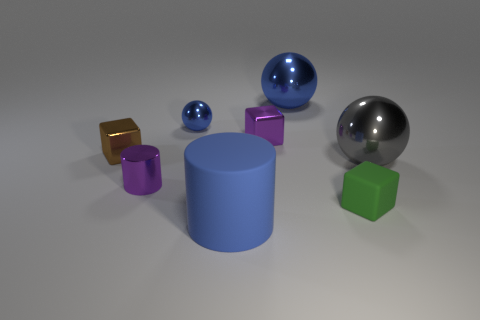Subtract all small spheres. How many spheres are left? 2 Subtract all yellow cubes. How many blue spheres are left? 2 Add 1 gray metallic objects. How many objects exist? 9 Subtract 1 blocks. How many blocks are left? 2 Subtract all balls. How many objects are left? 5 Subtract 1 blue cylinders. How many objects are left? 7 Subtract all purple spheres. Subtract all yellow cubes. How many spheres are left? 3 Subtract all big blue objects. Subtract all small matte blocks. How many objects are left? 5 Add 3 shiny cylinders. How many shiny cylinders are left? 4 Add 2 yellow matte balls. How many yellow matte balls exist? 2 